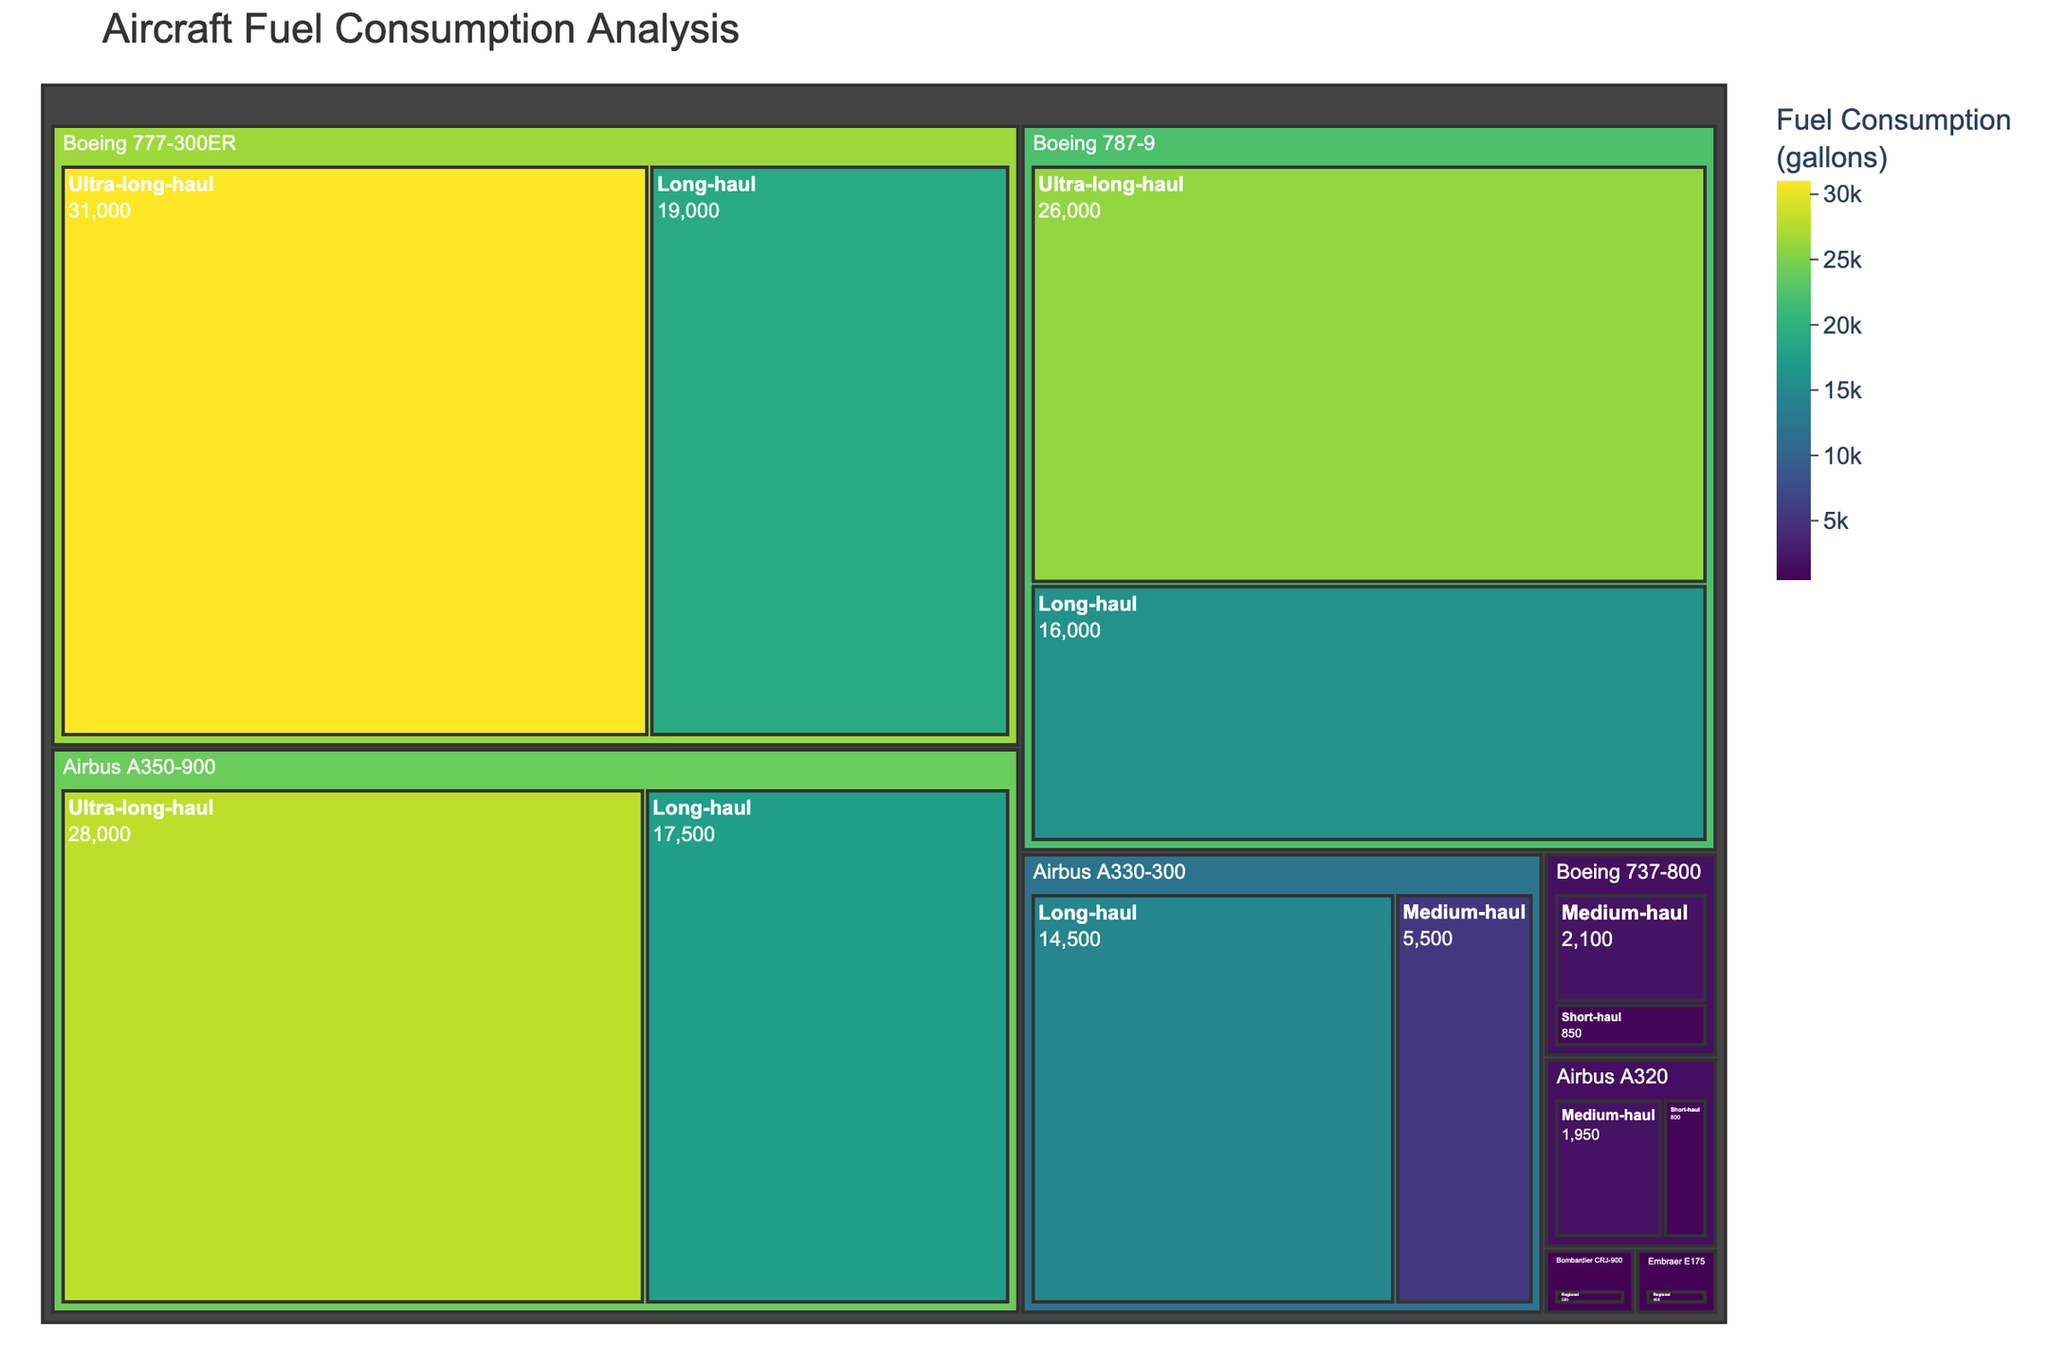Which aircraft type is shown to have the highest fuel consumption for ultra-long-haul flights? The treemap shows fuel consumption varying by flight distance and aircraft type. By inspecting the segments under "Ultra-long-haul," we can see that the Boeing 777-300ER has the highest fuel consumption at 31,000 gallons.
Answer: Boeing 777-300ER Which regional aircraft has the lowest fuel consumption? In the "Regional" category, the treemap indicates that the Embraer E175 consumes 450 gallons, which is lower compared to Bombardier CRJ-900 at 500 gallons.
Answer: Embraer E175 How does the fuel consumption of the Airbus A350-900 compare between long-haul and ultra-long-haul flights? By examining the treemap, for the Airbus A350-900, the fuel consumption is 17,500 gallons for long-haul and 28,000 gallons for ultra-long-haul. The comparison shows a significant increase in fuel consumption for ultra-long-haul flights.
Answer: Ultra-long-haul is 10,500 gallons more Which has a greater fuel consumption for medium-haul flights, Boeing 737-800 or Airbus A320? The Boeing 737-800 consumes 2,100 gallons for medium-haul, while the Airbus A320 consumes 1,950 gallons. By comparing these values, we can see that the Boeing 737-800 has a higher fuel consumption.
Answer: Boeing 737-800 What is the total fuel consumption for all regional flights? Summing the fuel consumption for the regional flights: Embraer E175 (450 gallons) and Bombardier CRJ-900 (500 gallons), we get 450 + 500 = 950 gallons.
Answer: 950 gallons How much more fuel does the Boeing 787-9 consume on ultra-long-haul flights compared to long-haul flights? The treemap shows that the Boeing 787-9 consumes 26,000 gallons for ultra-long-haul and 16,000 gallons for long-haul flights. The difference is 26,000 - 16,000 = 10,000 gallons.
Answer: 10,000 gallons more Which aircraft type and flight distance combination has the least fuel consumption? Looking at all segments, the lowest value shown is in the "Regional" category with the Embraer E175 consuming 450 gallons.
Answer: Embraer E175, Regional What is the title of the treemap figure? The title is displayed at the top of the figure and reads "Aircraft Fuel Consumption Analysis."
Answer: Aircraft Fuel Consumption Analysis How does the Boeing 777-300ER's fuel consumption for long-haul flights compare to the Airbus A330-300's medium-haul flights? The Boeing 777-300ER consumes 19,000 gallons for long-haul, while the Airbus A330-300 consumes 5,500 gallons for medium-haul. Therefore, the 777-300ER consumes significantly more fuel than the A330-300 for these flight distances.
Answer: Boeing 777-300ER consumes more 